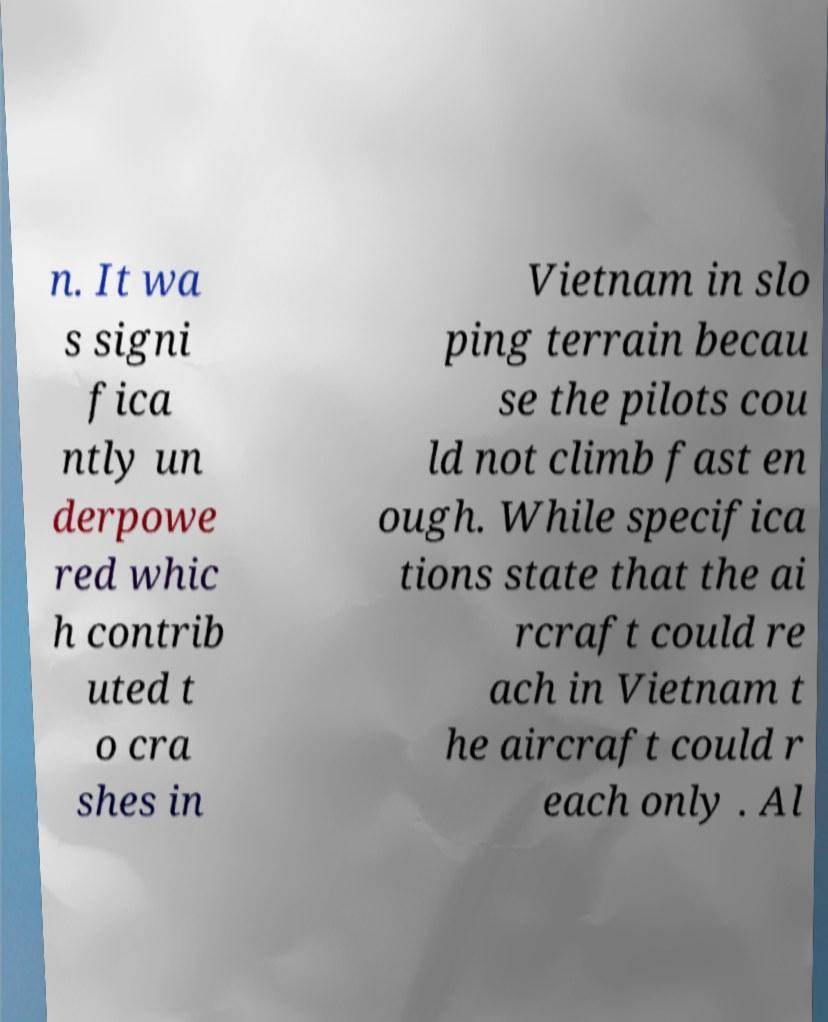Please read and relay the text visible in this image. What does it say? n. It wa s signi fica ntly un derpowe red whic h contrib uted t o cra shes in Vietnam in slo ping terrain becau se the pilots cou ld not climb fast en ough. While specifica tions state that the ai rcraft could re ach in Vietnam t he aircraft could r each only . Al 